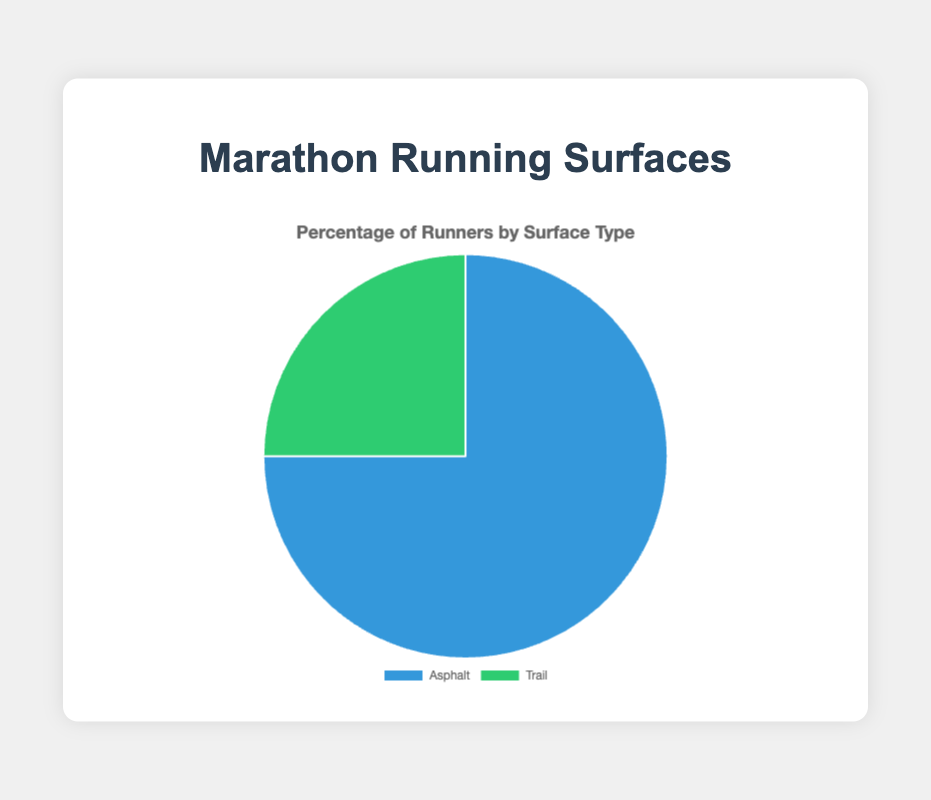Which surface has higher popularity among marathon events? The pie chart shows two surface types with their respective percentages of runners. Asphalt has a higher percentage at 75%, which indicates its greater popularity.
Answer: Asphalt Which surface type has fewer runners participating in marathon events? The pie chart shows that Trail has 25% of runners, which is lower than the 75% for Asphalt.
Answer: Trail What is the percentage difference between the number of runners on asphalt and trail surfaces? The difference in percentages between Asphalt (75%) and Trail (25%) is calculated as 75% - 25% = 50%.
Answer: 50% If 800 runners participate in a marathon, how many would likely run on trails? 25% of 800 runners would be 0.25 * 800 = 200.
Answer: 200 What surface type corresponds to the green segment in the pie chart? The green segment in the pie chart represents the Trail surface, as shown in the chart legend.
Answer: Trail If the total number of runners is doubled, how many more runners would participate in asphalt surface marathons compared to trail surfaces? Initially, for 100 runners, the breakdown would be 75 on Asphalt and 25 on Trail. Doubling the number would result in 150 more on Asphalt and 50 more on Trail, the difference being 150 - 50 = 100.
Answer: 100 If 1000 runners participated in a study, find the number of runners who chose asphalt. 75% of 1000 runners is calculated as 0.75 * 1000 = 750 runners.
Answer: 750 What color represents the surface type that the majority of runners prefer? The majority of runners (75%) prefer Asphalt, which corresponds to the blue segment in the pie chart.
Answer: Blue Between asphalt and trail surfaces, which one shows a minority preference for marathon events? The pie chart shows that Trail, with 25% of runners, has the minority preference compared to Asphalt’s 75%.
Answer: Trail Calculate the share of runners participating in marathons on asphalt surfaces if the total number of runners is 2000. Given that 75% of runners choose asphalt surfaces, for 2000 runners, the number would be 0.75 * 2000 = 1500 runners.
Answer: 1500 